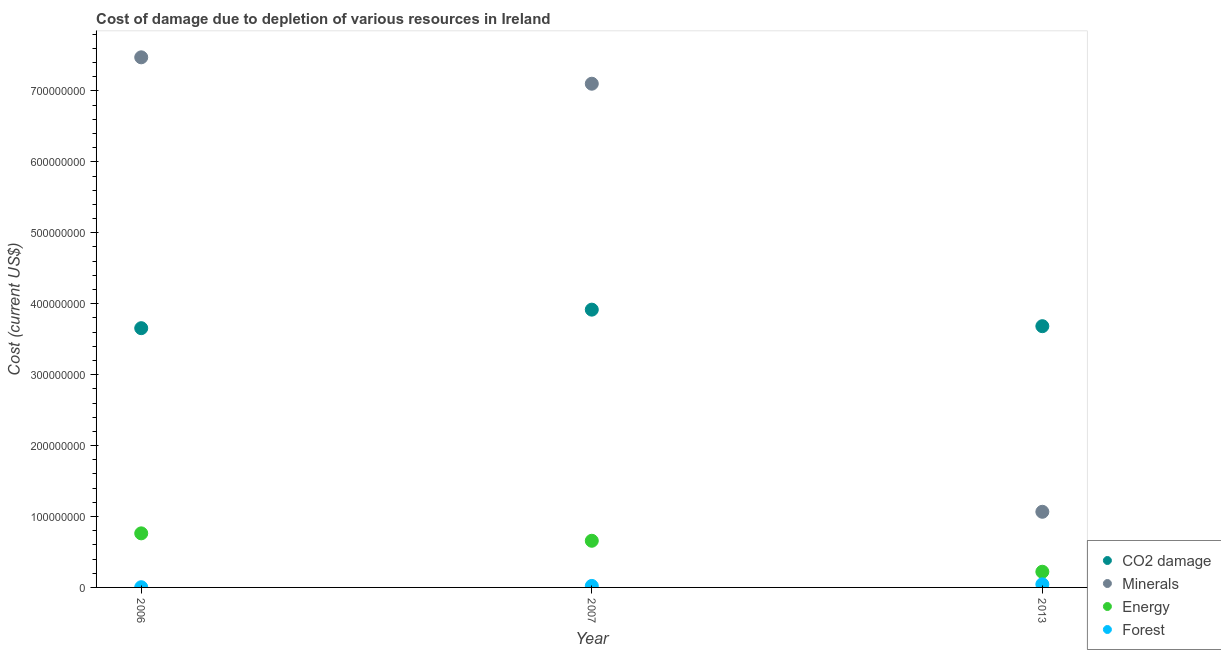What is the cost of damage due to depletion of coal in 2006?
Provide a succinct answer. 3.65e+08. Across all years, what is the maximum cost of damage due to depletion of coal?
Make the answer very short. 3.92e+08. Across all years, what is the minimum cost of damage due to depletion of coal?
Provide a succinct answer. 3.65e+08. What is the total cost of damage due to depletion of energy in the graph?
Keep it short and to the point. 1.64e+08. What is the difference between the cost of damage due to depletion of coal in 2006 and that in 2013?
Your answer should be very brief. -2.81e+06. What is the difference between the cost of damage due to depletion of energy in 2006 and the cost of damage due to depletion of minerals in 2013?
Provide a short and direct response. -3.04e+07. What is the average cost of damage due to depletion of minerals per year?
Make the answer very short. 5.21e+08. In the year 2013, what is the difference between the cost of damage due to depletion of coal and cost of damage due to depletion of energy?
Your answer should be compact. 3.46e+08. In how many years, is the cost of damage due to depletion of energy greater than 640000000 US$?
Keep it short and to the point. 0. What is the ratio of the cost of damage due to depletion of coal in 2006 to that in 2007?
Ensure brevity in your answer.  0.93. Is the cost of damage due to depletion of coal in 2006 less than that in 2013?
Offer a terse response. Yes. What is the difference between the highest and the second highest cost of damage due to depletion of minerals?
Make the answer very short. 3.72e+07. What is the difference between the highest and the lowest cost of damage due to depletion of coal?
Give a very brief answer. 2.61e+07. Is the sum of the cost of damage due to depletion of forests in 2007 and 2013 greater than the maximum cost of damage due to depletion of coal across all years?
Provide a short and direct response. No. Does the cost of damage due to depletion of minerals monotonically increase over the years?
Give a very brief answer. No. Is the cost of damage due to depletion of energy strictly greater than the cost of damage due to depletion of minerals over the years?
Your response must be concise. No. How many years are there in the graph?
Provide a short and direct response. 3. What is the difference between two consecutive major ticks on the Y-axis?
Your response must be concise. 1.00e+08. Are the values on the major ticks of Y-axis written in scientific E-notation?
Keep it short and to the point. No. Does the graph contain any zero values?
Provide a short and direct response. No. Does the graph contain grids?
Keep it short and to the point. No. How many legend labels are there?
Give a very brief answer. 4. How are the legend labels stacked?
Make the answer very short. Vertical. What is the title of the graph?
Give a very brief answer. Cost of damage due to depletion of various resources in Ireland . Does "CO2 damage" appear as one of the legend labels in the graph?
Provide a succinct answer. Yes. What is the label or title of the X-axis?
Your answer should be compact. Year. What is the label or title of the Y-axis?
Offer a very short reply. Cost (current US$). What is the Cost (current US$) of CO2 damage in 2006?
Give a very brief answer. 3.65e+08. What is the Cost (current US$) in Minerals in 2006?
Your answer should be very brief. 7.47e+08. What is the Cost (current US$) in Energy in 2006?
Your answer should be compact. 7.62e+07. What is the Cost (current US$) in Forest in 2006?
Give a very brief answer. 2.94e+05. What is the Cost (current US$) of CO2 damage in 2007?
Provide a short and direct response. 3.92e+08. What is the Cost (current US$) in Minerals in 2007?
Ensure brevity in your answer.  7.10e+08. What is the Cost (current US$) of Energy in 2007?
Keep it short and to the point. 6.58e+07. What is the Cost (current US$) of Forest in 2007?
Offer a terse response. 2.10e+06. What is the Cost (current US$) of CO2 damage in 2013?
Offer a terse response. 3.68e+08. What is the Cost (current US$) in Minerals in 2013?
Your answer should be very brief. 1.07e+08. What is the Cost (current US$) in Energy in 2013?
Provide a short and direct response. 2.21e+07. What is the Cost (current US$) in Forest in 2013?
Make the answer very short. 4.37e+06. Across all years, what is the maximum Cost (current US$) in CO2 damage?
Ensure brevity in your answer.  3.92e+08. Across all years, what is the maximum Cost (current US$) of Minerals?
Keep it short and to the point. 7.47e+08. Across all years, what is the maximum Cost (current US$) in Energy?
Offer a very short reply. 7.62e+07. Across all years, what is the maximum Cost (current US$) of Forest?
Offer a very short reply. 4.37e+06. Across all years, what is the minimum Cost (current US$) of CO2 damage?
Ensure brevity in your answer.  3.65e+08. Across all years, what is the minimum Cost (current US$) in Minerals?
Make the answer very short. 1.07e+08. Across all years, what is the minimum Cost (current US$) of Energy?
Offer a very short reply. 2.21e+07. Across all years, what is the minimum Cost (current US$) in Forest?
Offer a very short reply. 2.94e+05. What is the total Cost (current US$) of CO2 damage in the graph?
Your answer should be compact. 1.13e+09. What is the total Cost (current US$) of Minerals in the graph?
Provide a succinct answer. 1.56e+09. What is the total Cost (current US$) in Energy in the graph?
Your answer should be compact. 1.64e+08. What is the total Cost (current US$) in Forest in the graph?
Provide a short and direct response. 6.76e+06. What is the difference between the Cost (current US$) in CO2 damage in 2006 and that in 2007?
Provide a short and direct response. -2.61e+07. What is the difference between the Cost (current US$) in Minerals in 2006 and that in 2007?
Offer a terse response. 3.72e+07. What is the difference between the Cost (current US$) of Energy in 2006 and that in 2007?
Your response must be concise. 1.05e+07. What is the difference between the Cost (current US$) in Forest in 2006 and that in 2007?
Provide a succinct answer. -1.81e+06. What is the difference between the Cost (current US$) in CO2 damage in 2006 and that in 2013?
Your answer should be very brief. -2.81e+06. What is the difference between the Cost (current US$) in Minerals in 2006 and that in 2013?
Your answer should be very brief. 6.41e+08. What is the difference between the Cost (current US$) in Energy in 2006 and that in 2013?
Provide a short and direct response. 5.41e+07. What is the difference between the Cost (current US$) of Forest in 2006 and that in 2013?
Make the answer very short. -4.07e+06. What is the difference between the Cost (current US$) of CO2 damage in 2007 and that in 2013?
Offer a terse response. 2.33e+07. What is the difference between the Cost (current US$) in Minerals in 2007 and that in 2013?
Your answer should be compact. 6.04e+08. What is the difference between the Cost (current US$) of Energy in 2007 and that in 2013?
Offer a very short reply. 4.37e+07. What is the difference between the Cost (current US$) of Forest in 2007 and that in 2013?
Make the answer very short. -2.27e+06. What is the difference between the Cost (current US$) in CO2 damage in 2006 and the Cost (current US$) in Minerals in 2007?
Your response must be concise. -3.45e+08. What is the difference between the Cost (current US$) in CO2 damage in 2006 and the Cost (current US$) in Energy in 2007?
Make the answer very short. 3.00e+08. What is the difference between the Cost (current US$) in CO2 damage in 2006 and the Cost (current US$) in Forest in 2007?
Your answer should be very brief. 3.63e+08. What is the difference between the Cost (current US$) of Minerals in 2006 and the Cost (current US$) of Energy in 2007?
Your answer should be very brief. 6.82e+08. What is the difference between the Cost (current US$) in Minerals in 2006 and the Cost (current US$) in Forest in 2007?
Your response must be concise. 7.45e+08. What is the difference between the Cost (current US$) of Energy in 2006 and the Cost (current US$) of Forest in 2007?
Provide a succinct answer. 7.41e+07. What is the difference between the Cost (current US$) in CO2 damage in 2006 and the Cost (current US$) in Minerals in 2013?
Provide a succinct answer. 2.59e+08. What is the difference between the Cost (current US$) in CO2 damage in 2006 and the Cost (current US$) in Energy in 2013?
Your answer should be compact. 3.43e+08. What is the difference between the Cost (current US$) in CO2 damage in 2006 and the Cost (current US$) in Forest in 2013?
Provide a succinct answer. 3.61e+08. What is the difference between the Cost (current US$) in Minerals in 2006 and the Cost (current US$) in Energy in 2013?
Your answer should be very brief. 7.25e+08. What is the difference between the Cost (current US$) of Minerals in 2006 and the Cost (current US$) of Forest in 2013?
Keep it short and to the point. 7.43e+08. What is the difference between the Cost (current US$) of Energy in 2006 and the Cost (current US$) of Forest in 2013?
Make the answer very short. 7.19e+07. What is the difference between the Cost (current US$) of CO2 damage in 2007 and the Cost (current US$) of Minerals in 2013?
Your answer should be compact. 2.85e+08. What is the difference between the Cost (current US$) of CO2 damage in 2007 and the Cost (current US$) of Energy in 2013?
Keep it short and to the point. 3.70e+08. What is the difference between the Cost (current US$) in CO2 damage in 2007 and the Cost (current US$) in Forest in 2013?
Ensure brevity in your answer.  3.87e+08. What is the difference between the Cost (current US$) in Minerals in 2007 and the Cost (current US$) in Energy in 2013?
Give a very brief answer. 6.88e+08. What is the difference between the Cost (current US$) of Minerals in 2007 and the Cost (current US$) of Forest in 2013?
Give a very brief answer. 7.06e+08. What is the difference between the Cost (current US$) of Energy in 2007 and the Cost (current US$) of Forest in 2013?
Your response must be concise. 6.14e+07. What is the average Cost (current US$) of CO2 damage per year?
Provide a succinct answer. 3.75e+08. What is the average Cost (current US$) of Minerals per year?
Your answer should be compact. 5.21e+08. What is the average Cost (current US$) in Energy per year?
Offer a very short reply. 5.47e+07. What is the average Cost (current US$) of Forest per year?
Offer a terse response. 2.25e+06. In the year 2006, what is the difference between the Cost (current US$) of CO2 damage and Cost (current US$) of Minerals?
Offer a terse response. -3.82e+08. In the year 2006, what is the difference between the Cost (current US$) of CO2 damage and Cost (current US$) of Energy?
Provide a succinct answer. 2.89e+08. In the year 2006, what is the difference between the Cost (current US$) in CO2 damage and Cost (current US$) in Forest?
Make the answer very short. 3.65e+08. In the year 2006, what is the difference between the Cost (current US$) in Minerals and Cost (current US$) in Energy?
Your response must be concise. 6.71e+08. In the year 2006, what is the difference between the Cost (current US$) in Minerals and Cost (current US$) in Forest?
Offer a terse response. 7.47e+08. In the year 2006, what is the difference between the Cost (current US$) of Energy and Cost (current US$) of Forest?
Ensure brevity in your answer.  7.59e+07. In the year 2007, what is the difference between the Cost (current US$) in CO2 damage and Cost (current US$) in Minerals?
Offer a very short reply. -3.19e+08. In the year 2007, what is the difference between the Cost (current US$) in CO2 damage and Cost (current US$) in Energy?
Provide a short and direct response. 3.26e+08. In the year 2007, what is the difference between the Cost (current US$) of CO2 damage and Cost (current US$) of Forest?
Offer a terse response. 3.90e+08. In the year 2007, what is the difference between the Cost (current US$) in Minerals and Cost (current US$) in Energy?
Your response must be concise. 6.44e+08. In the year 2007, what is the difference between the Cost (current US$) in Minerals and Cost (current US$) in Forest?
Provide a succinct answer. 7.08e+08. In the year 2007, what is the difference between the Cost (current US$) of Energy and Cost (current US$) of Forest?
Keep it short and to the point. 6.37e+07. In the year 2013, what is the difference between the Cost (current US$) in CO2 damage and Cost (current US$) in Minerals?
Your response must be concise. 2.62e+08. In the year 2013, what is the difference between the Cost (current US$) of CO2 damage and Cost (current US$) of Energy?
Ensure brevity in your answer.  3.46e+08. In the year 2013, what is the difference between the Cost (current US$) of CO2 damage and Cost (current US$) of Forest?
Provide a short and direct response. 3.64e+08. In the year 2013, what is the difference between the Cost (current US$) in Minerals and Cost (current US$) in Energy?
Provide a short and direct response. 8.45e+07. In the year 2013, what is the difference between the Cost (current US$) in Minerals and Cost (current US$) in Forest?
Your answer should be compact. 1.02e+08. In the year 2013, what is the difference between the Cost (current US$) of Energy and Cost (current US$) of Forest?
Give a very brief answer. 1.77e+07. What is the ratio of the Cost (current US$) in Minerals in 2006 to that in 2007?
Provide a succinct answer. 1.05. What is the ratio of the Cost (current US$) of Energy in 2006 to that in 2007?
Your answer should be compact. 1.16. What is the ratio of the Cost (current US$) of Forest in 2006 to that in 2007?
Your response must be concise. 0.14. What is the ratio of the Cost (current US$) in CO2 damage in 2006 to that in 2013?
Offer a terse response. 0.99. What is the ratio of the Cost (current US$) of Minerals in 2006 to that in 2013?
Your answer should be very brief. 7.01. What is the ratio of the Cost (current US$) in Energy in 2006 to that in 2013?
Offer a very short reply. 3.45. What is the ratio of the Cost (current US$) in Forest in 2006 to that in 2013?
Your answer should be compact. 0.07. What is the ratio of the Cost (current US$) of CO2 damage in 2007 to that in 2013?
Make the answer very short. 1.06. What is the ratio of the Cost (current US$) in Minerals in 2007 to that in 2013?
Ensure brevity in your answer.  6.66. What is the ratio of the Cost (current US$) of Energy in 2007 to that in 2013?
Give a very brief answer. 2.97. What is the ratio of the Cost (current US$) of Forest in 2007 to that in 2013?
Ensure brevity in your answer.  0.48. What is the difference between the highest and the second highest Cost (current US$) in CO2 damage?
Your answer should be very brief. 2.33e+07. What is the difference between the highest and the second highest Cost (current US$) of Minerals?
Provide a succinct answer. 3.72e+07. What is the difference between the highest and the second highest Cost (current US$) of Energy?
Provide a short and direct response. 1.05e+07. What is the difference between the highest and the second highest Cost (current US$) of Forest?
Keep it short and to the point. 2.27e+06. What is the difference between the highest and the lowest Cost (current US$) in CO2 damage?
Keep it short and to the point. 2.61e+07. What is the difference between the highest and the lowest Cost (current US$) of Minerals?
Your answer should be compact. 6.41e+08. What is the difference between the highest and the lowest Cost (current US$) of Energy?
Keep it short and to the point. 5.41e+07. What is the difference between the highest and the lowest Cost (current US$) in Forest?
Offer a very short reply. 4.07e+06. 